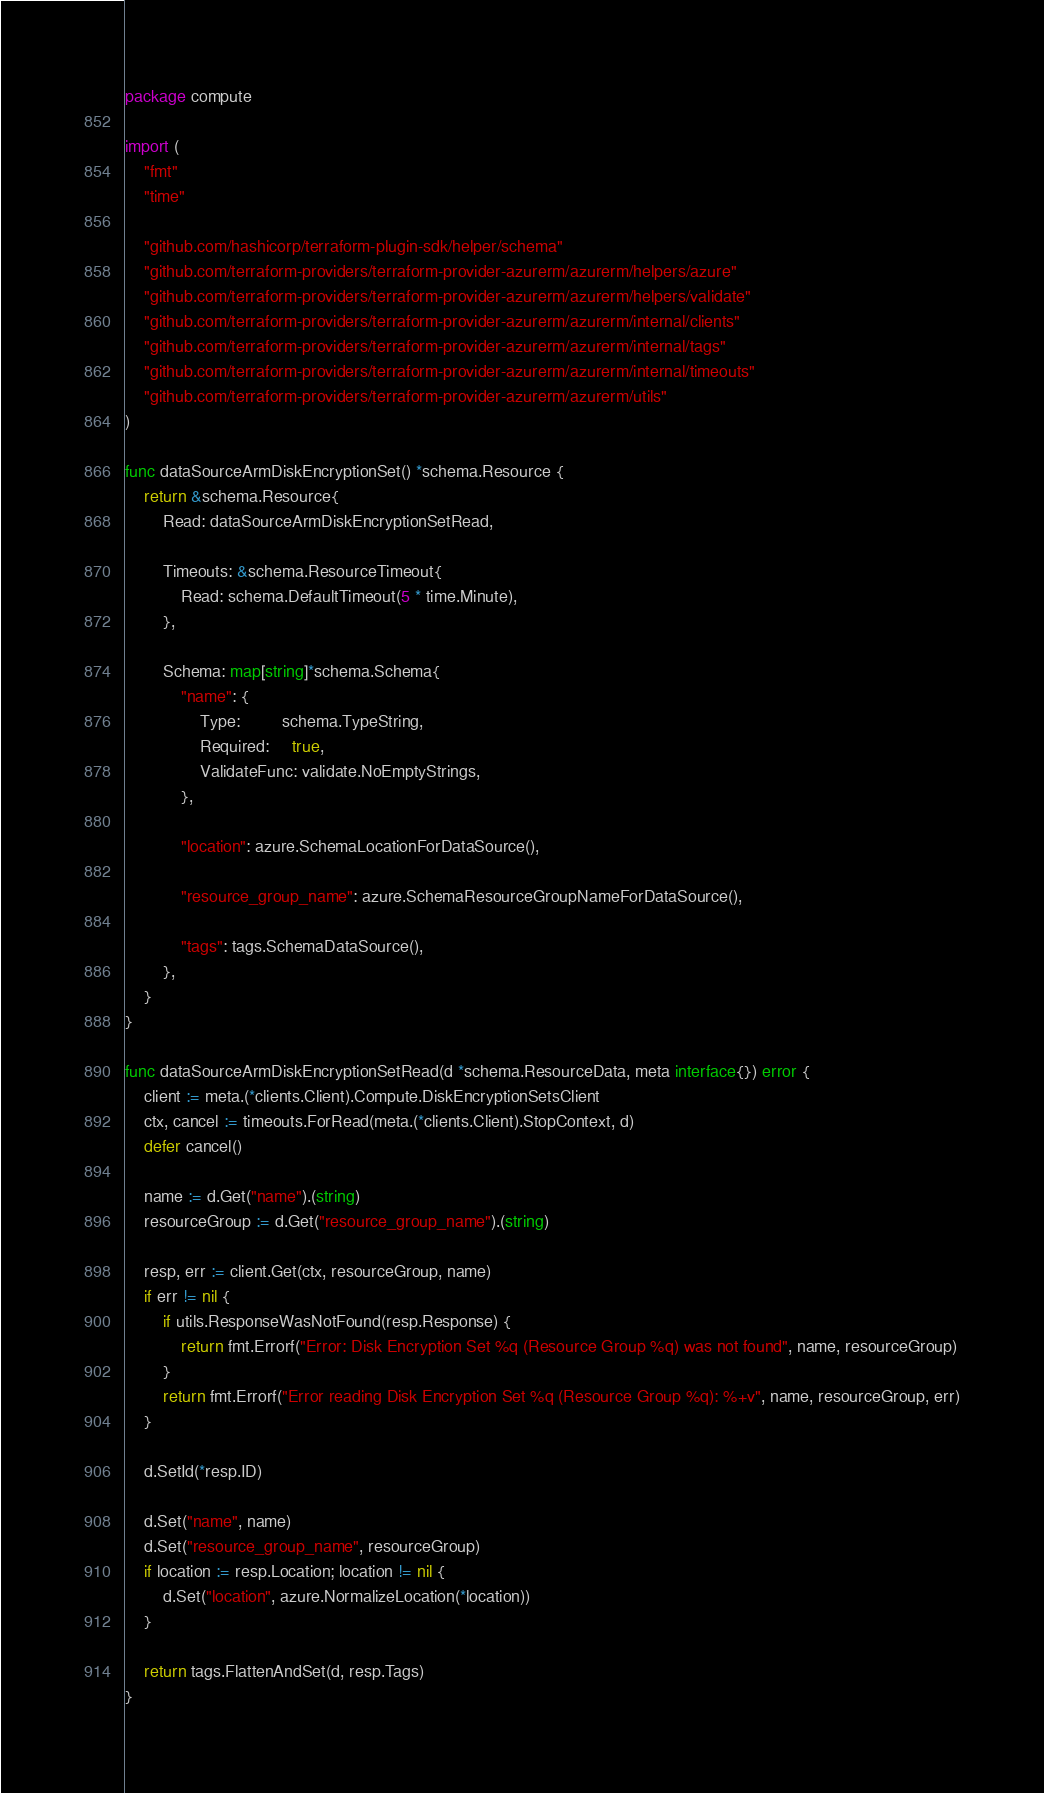<code> <loc_0><loc_0><loc_500><loc_500><_Go_>package compute

import (
	"fmt"
	"time"

	"github.com/hashicorp/terraform-plugin-sdk/helper/schema"
	"github.com/terraform-providers/terraform-provider-azurerm/azurerm/helpers/azure"
	"github.com/terraform-providers/terraform-provider-azurerm/azurerm/helpers/validate"
	"github.com/terraform-providers/terraform-provider-azurerm/azurerm/internal/clients"
	"github.com/terraform-providers/terraform-provider-azurerm/azurerm/internal/tags"
	"github.com/terraform-providers/terraform-provider-azurerm/azurerm/internal/timeouts"
	"github.com/terraform-providers/terraform-provider-azurerm/azurerm/utils"
)

func dataSourceArmDiskEncryptionSet() *schema.Resource {
	return &schema.Resource{
		Read: dataSourceArmDiskEncryptionSetRead,

		Timeouts: &schema.ResourceTimeout{
			Read: schema.DefaultTimeout(5 * time.Minute),
		},

		Schema: map[string]*schema.Schema{
			"name": {
				Type:         schema.TypeString,
				Required:     true,
				ValidateFunc: validate.NoEmptyStrings,
			},

			"location": azure.SchemaLocationForDataSource(),

			"resource_group_name": azure.SchemaResourceGroupNameForDataSource(),

			"tags": tags.SchemaDataSource(),
		},
	}
}

func dataSourceArmDiskEncryptionSetRead(d *schema.ResourceData, meta interface{}) error {
	client := meta.(*clients.Client).Compute.DiskEncryptionSetsClient
	ctx, cancel := timeouts.ForRead(meta.(*clients.Client).StopContext, d)
	defer cancel()

	name := d.Get("name").(string)
	resourceGroup := d.Get("resource_group_name").(string)

	resp, err := client.Get(ctx, resourceGroup, name)
	if err != nil {
		if utils.ResponseWasNotFound(resp.Response) {
			return fmt.Errorf("Error: Disk Encryption Set %q (Resource Group %q) was not found", name, resourceGroup)
		}
		return fmt.Errorf("Error reading Disk Encryption Set %q (Resource Group %q): %+v", name, resourceGroup, err)
	}

	d.SetId(*resp.ID)

	d.Set("name", name)
	d.Set("resource_group_name", resourceGroup)
	if location := resp.Location; location != nil {
		d.Set("location", azure.NormalizeLocation(*location))
	}

	return tags.FlattenAndSet(d, resp.Tags)
}
</code> 